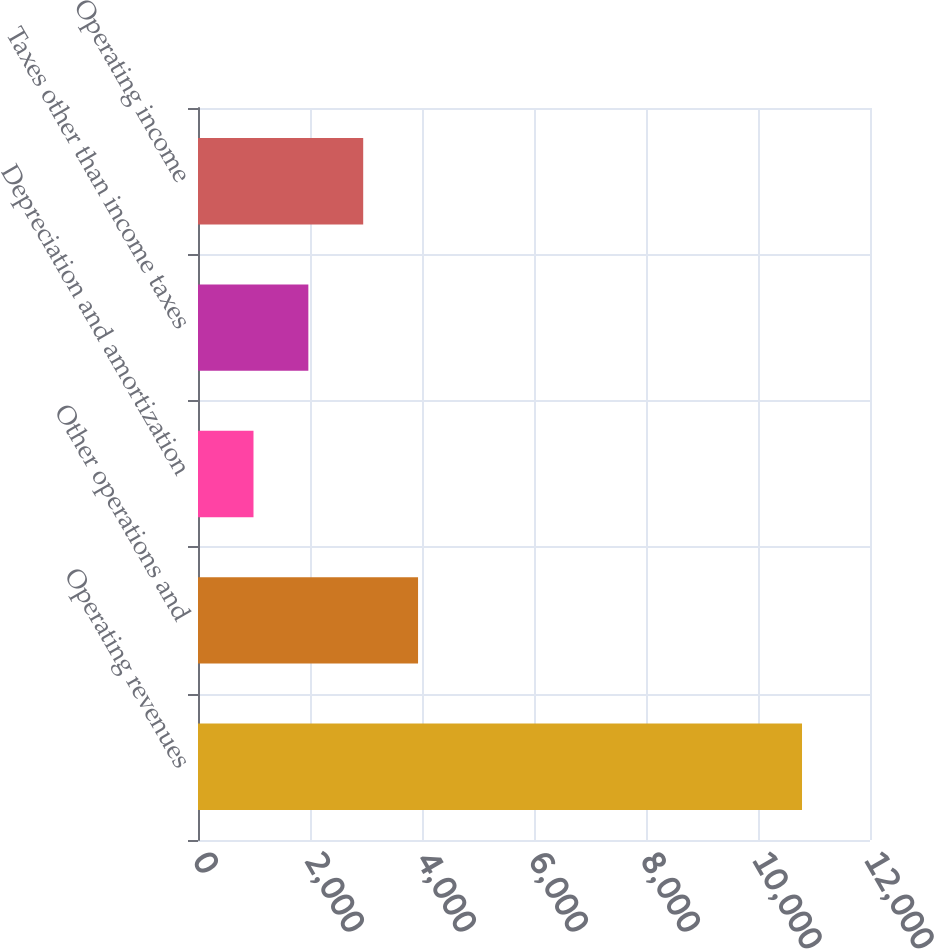Convert chart to OTSL. <chart><loc_0><loc_0><loc_500><loc_500><bar_chart><fcel>Operating revenues<fcel>Other operations and<fcel>Depreciation and amortization<fcel>Taxes other than income taxes<fcel>Operating income<nl><fcel>10786<fcel>3929.5<fcel>991<fcel>1970.5<fcel>2950<nl></chart> 